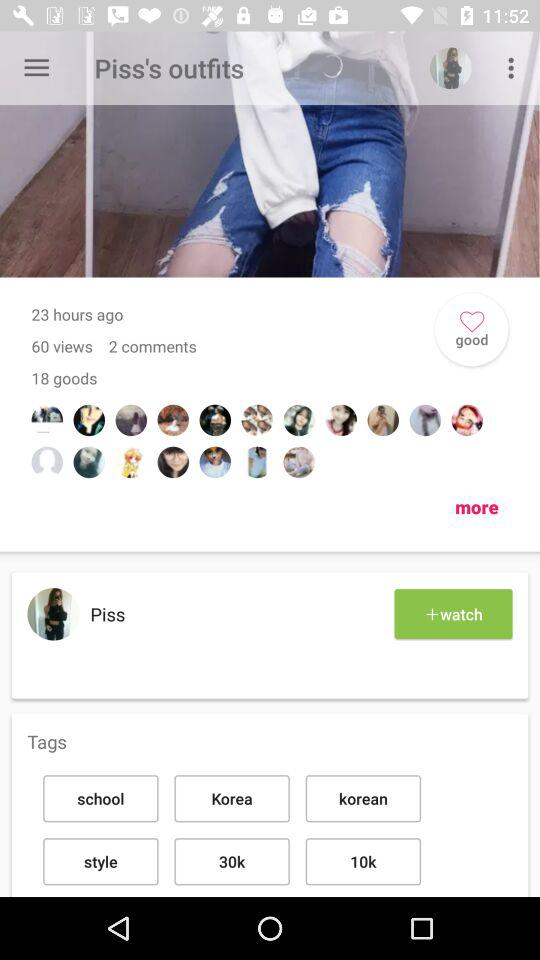How many hours ago was the post posted? The post was posted 23 hours ago. 